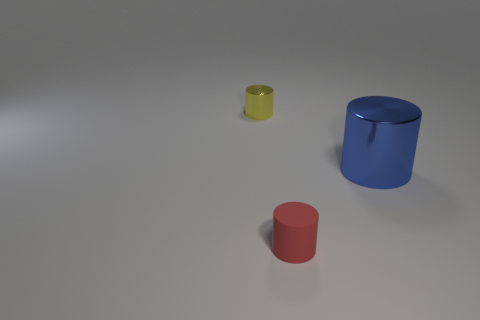Add 2 brown shiny things. How many objects exist? 5 Add 2 purple balls. How many purple balls exist? 2 Subtract 1 yellow cylinders. How many objects are left? 2 Subtract all tiny yellow objects. Subtract all metal objects. How many objects are left? 0 Add 3 rubber things. How many rubber things are left? 4 